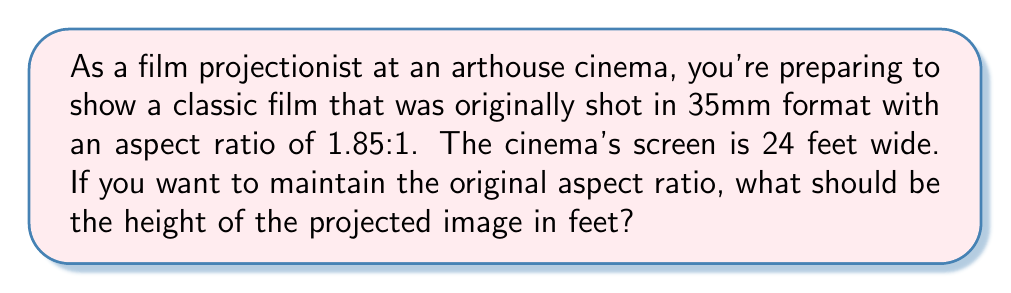Provide a solution to this math problem. To solve this problem, we need to understand the concept of aspect ratio and use basic algebra. Let's break it down step-by-step:

1) The aspect ratio is the ratio of the width to the height of an image. In this case, it's 1.85:1.

2) We can express this as an equation:
   $\frac{\text{width}}{\text{height}} = 1.85$

3) We know the width of the screen is 24 feet. Let's call the unknown height $h$. Substituting these into our equation:
   $\frac{24}{h} = 1.85$

4) To solve for $h$, we can cross-multiply:
   $24 = 1.85h$

5) Now, we can divide both sides by 1.85:
   $\frac{24}{1.85} = h$

6) Using a calculator or dividing:
   $h \approx 12.97$ feet

Therefore, to maintain the original aspect ratio of 1.85:1 on a 24-foot wide screen, the height of the projected image should be approximately 12.97 feet.
Answer: $h \approx 12.97$ feet 